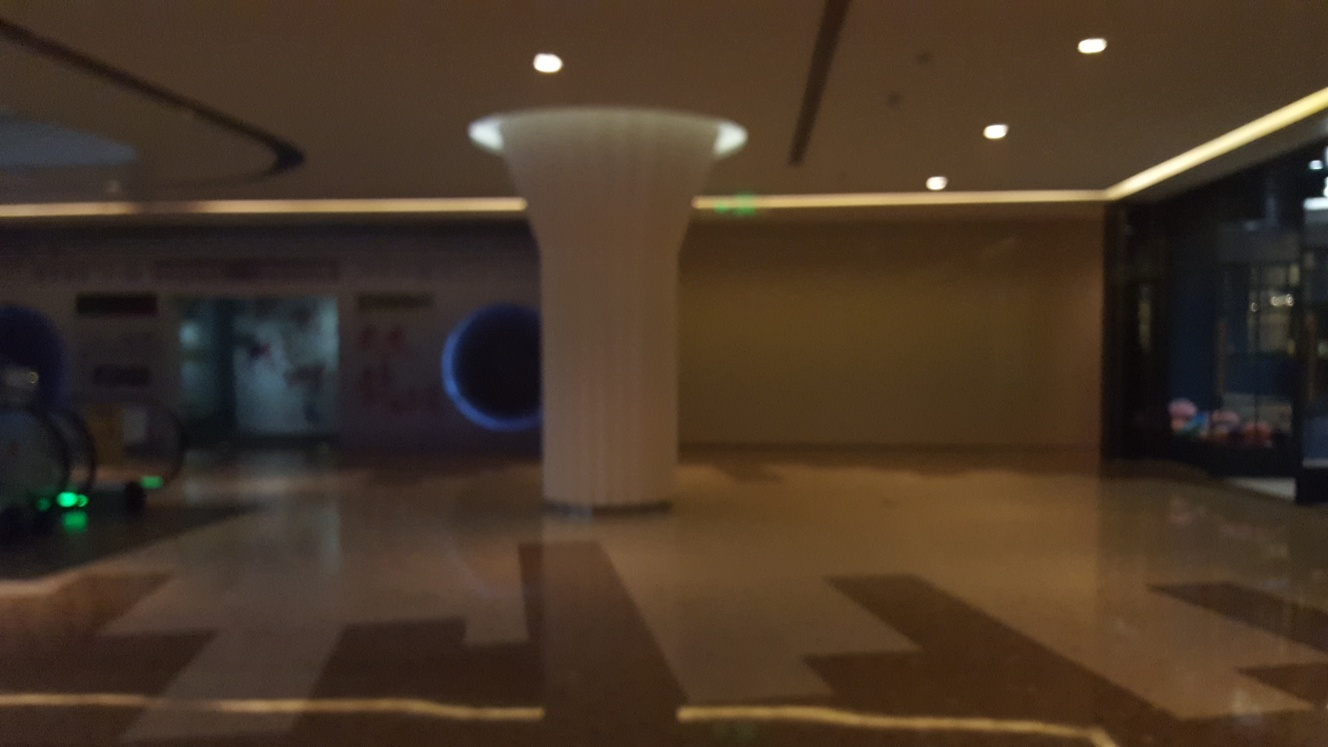What can you tell me about the architectural style? The photo showcases modern architectural elements such as clean lines, minimalistic design, and an open-space concept. The central pillar stands out with its widened top, suggesting a contemporary touch, and the stylish yet functional design adds to a modern, sleek aesthetic. 